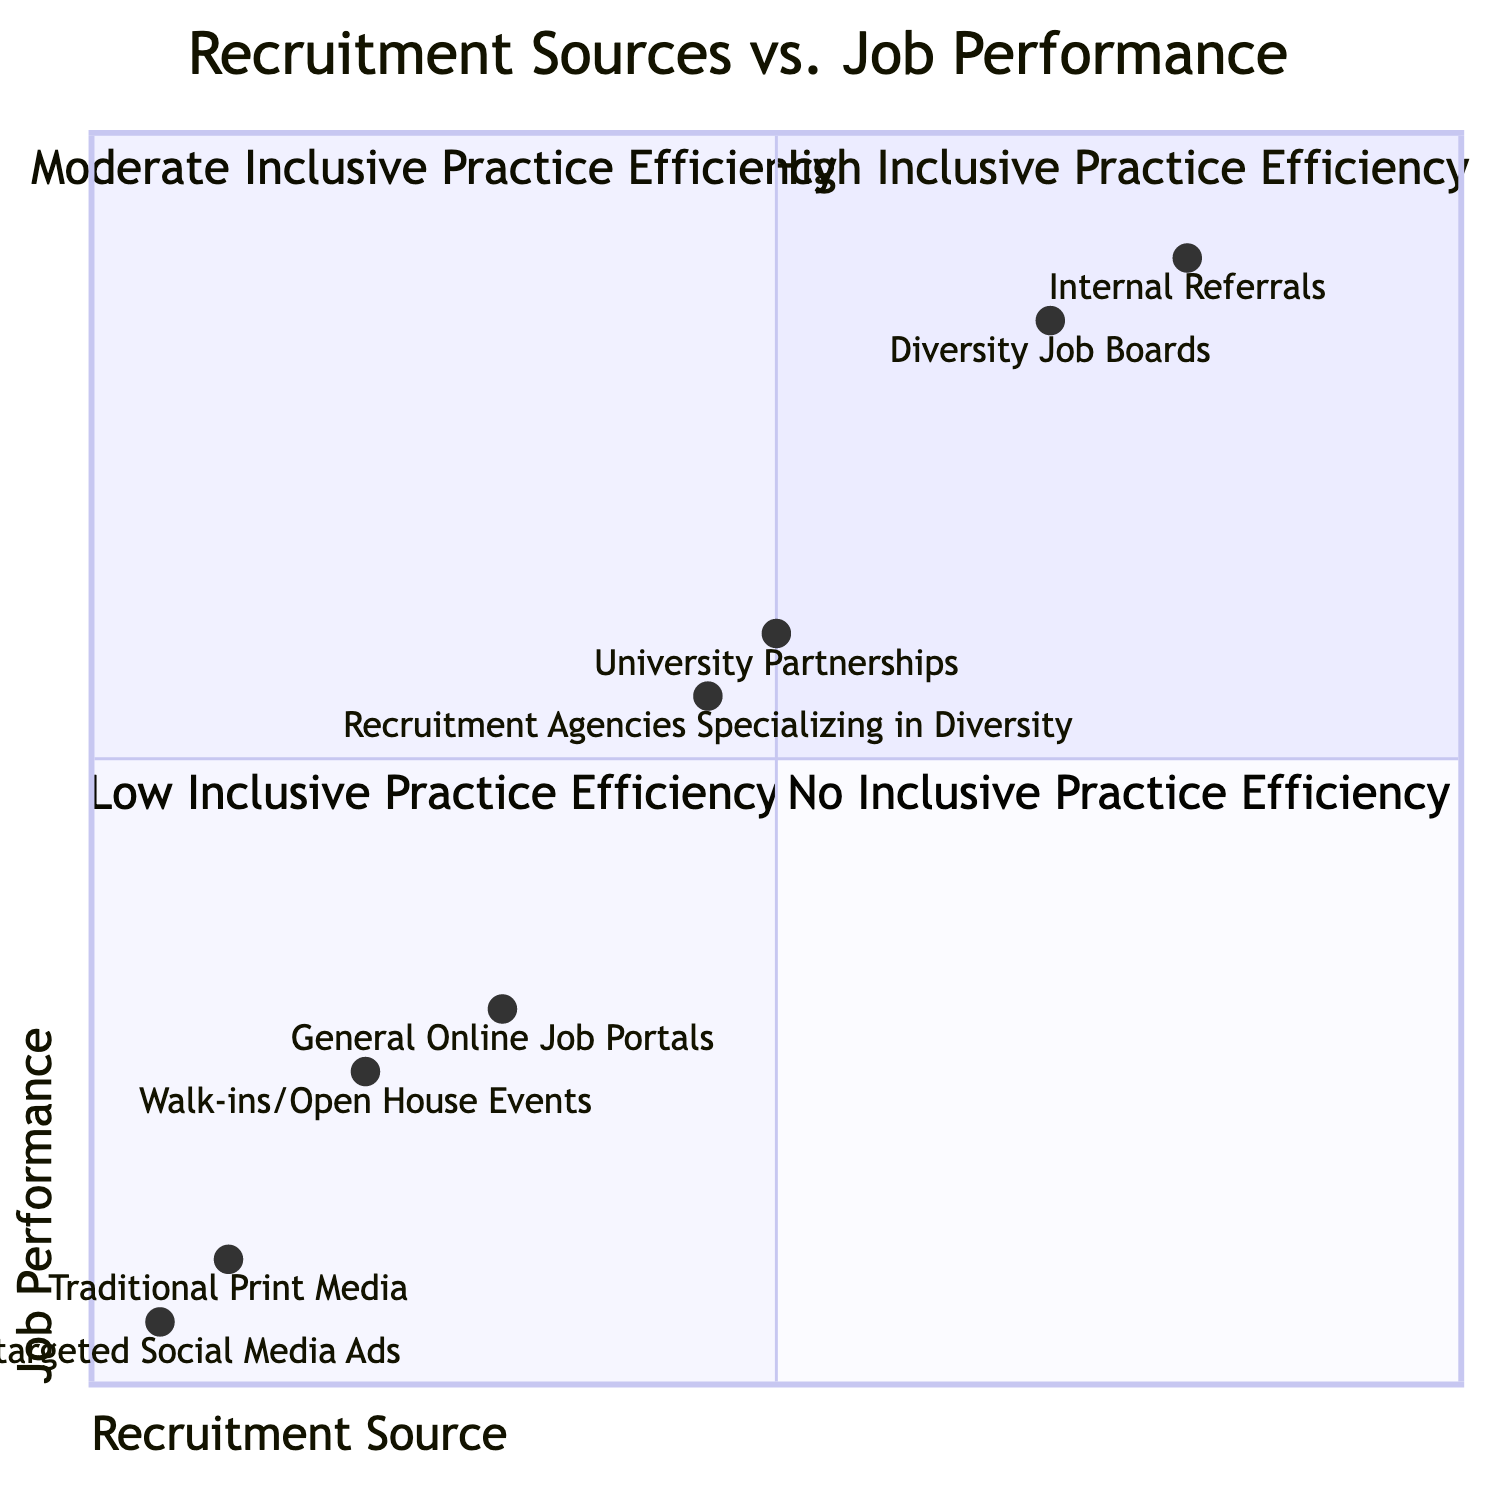What recruitment source has the highest job performance? The highest job performance is found in the 'Internal Referrals' source, as indicated in the upper right quadrant labeled 'High Inclusive Practice Efficiency'.
Answer: Internal Referrals Which recruitment source has the lowest job performance? The 'Non-targeted Social Media Ads' has the lowest job performance in the 'No Inclusive Practice Efficiency' quadrant, positioned in the lower right.
Answer: Non-targeted Social Media Ads How many recruitment sources fall under 'Low Inclusive Practice Efficiency'? There are two sources in the 'Low Inclusive Practice Efficiency' quadrant: 'General Online Job Portals' and 'Walk-ins/Open House Events'.
Answer: 2 What is the job performance level associated with 'University Partnerships'? 'University Partnerships' is associated with a 'Moderate' job performance level, located in the 'Moderate Inclusive Practice Efficiency' quadrant.
Answer: Moderate Which quadrant contains sources with 'Very Low' job performance? The 'No Inclusive Practice Efficiency' quadrant contains the sources that have a 'Very Low' job performance, as seen in the lower right section of the diagram.
Answer: No Inclusive Practice Efficiency What recruitment source reported high job performance but moderate inclusive practice efficiency? The 'University Partnerships' demonstrates moderate inclusive practice efficiency while showing moderate job performance, as detailed in the corresponding quadrant.
Answer: University Partnerships How does 'Diversity Job Boards' compare to 'Walk-ins/Open House Events' in terms of job performance? 'Diversity Job Boards' reports high job performance, while 'Walk-ins/Open House Events' shows low job performance, placing them in different quadrants.
Answer: Higher What is the quadrant for 'Traditional Print Media'? 'Traditional Print Media' is found in the 'No Inclusive Practice Efficiency' quadrant, characterized by very low job performance.
Answer: No Inclusive Practice Efficiency Which recruitment sources are located in the 'High Inclusive Practice Efficiency' quadrant? The 'High Inclusive Practice Efficiency' quadrant includes 'Internal Referrals' and 'Diversity Job Boards', as per the data represented in the diagram.
Answer: Internal Referrals, Diversity Job Boards 